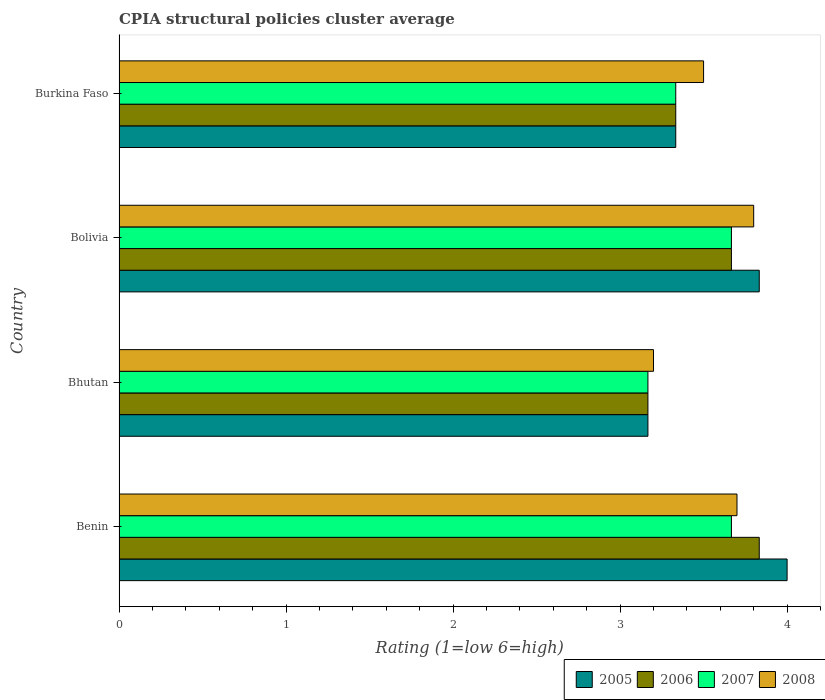How many groups of bars are there?
Your answer should be very brief. 4. Are the number of bars per tick equal to the number of legend labels?
Your response must be concise. Yes. Are the number of bars on each tick of the Y-axis equal?
Your answer should be compact. Yes. How many bars are there on the 2nd tick from the top?
Make the answer very short. 4. In how many cases, is the number of bars for a given country not equal to the number of legend labels?
Your answer should be very brief. 0. What is the CPIA rating in 2005 in Bolivia?
Your response must be concise. 3.83. Across all countries, what is the minimum CPIA rating in 2006?
Provide a short and direct response. 3.17. In which country was the CPIA rating in 2007 maximum?
Give a very brief answer. Benin. In which country was the CPIA rating in 2005 minimum?
Keep it short and to the point. Bhutan. What is the total CPIA rating in 2006 in the graph?
Offer a very short reply. 14. What is the difference between the CPIA rating in 2005 in Benin and that in Bolivia?
Your answer should be compact. 0.17. What is the average CPIA rating in 2006 per country?
Your answer should be compact. 3.5. What is the difference between the CPIA rating in 2008 and CPIA rating in 2007 in Burkina Faso?
Your answer should be very brief. 0.17. In how many countries, is the CPIA rating in 2007 greater than 1.4 ?
Give a very brief answer. 4. What is the ratio of the CPIA rating in 2007 in Benin to that in Burkina Faso?
Provide a short and direct response. 1.1. Is the CPIA rating in 2006 in Bhutan less than that in Bolivia?
Ensure brevity in your answer.  Yes. What is the difference between the highest and the second highest CPIA rating in 2007?
Make the answer very short. 0. What is the difference between the highest and the lowest CPIA rating in 2006?
Your response must be concise. 0.67. In how many countries, is the CPIA rating in 2008 greater than the average CPIA rating in 2008 taken over all countries?
Keep it short and to the point. 2. Is it the case that in every country, the sum of the CPIA rating in 2008 and CPIA rating in 2005 is greater than the sum of CPIA rating in 2007 and CPIA rating in 2006?
Give a very brief answer. No. What does the 3rd bar from the top in Benin represents?
Keep it short and to the point. 2006. Is it the case that in every country, the sum of the CPIA rating in 2008 and CPIA rating in 2005 is greater than the CPIA rating in 2007?
Give a very brief answer. Yes. How many bars are there?
Give a very brief answer. 16. Are the values on the major ticks of X-axis written in scientific E-notation?
Your answer should be very brief. No. Does the graph contain any zero values?
Give a very brief answer. No. How many legend labels are there?
Your response must be concise. 4. How are the legend labels stacked?
Your answer should be compact. Horizontal. What is the title of the graph?
Offer a terse response. CPIA structural policies cluster average. What is the Rating (1=low 6=high) in 2005 in Benin?
Make the answer very short. 4. What is the Rating (1=low 6=high) in 2006 in Benin?
Your answer should be compact. 3.83. What is the Rating (1=low 6=high) of 2007 in Benin?
Your response must be concise. 3.67. What is the Rating (1=low 6=high) in 2005 in Bhutan?
Ensure brevity in your answer.  3.17. What is the Rating (1=low 6=high) of 2006 in Bhutan?
Give a very brief answer. 3.17. What is the Rating (1=low 6=high) in 2007 in Bhutan?
Offer a terse response. 3.17. What is the Rating (1=low 6=high) of 2008 in Bhutan?
Your answer should be very brief. 3.2. What is the Rating (1=low 6=high) of 2005 in Bolivia?
Keep it short and to the point. 3.83. What is the Rating (1=low 6=high) of 2006 in Bolivia?
Your answer should be very brief. 3.67. What is the Rating (1=low 6=high) of 2007 in Bolivia?
Provide a short and direct response. 3.67. What is the Rating (1=low 6=high) of 2005 in Burkina Faso?
Offer a very short reply. 3.33. What is the Rating (1=low 6=high) of 2006 in Burkina Faso?
Offer a very short reply. 3.33. What is the Rating (1=low 6=high) in 2007 in Burkina Faso?
Your answer should be very brief. 3.33. What is the Rating (1=low 6=high) of 2008 in Burkina Faso?
Offer a very short reply. 3.5. Across all countries, what is the maximum Rating (1=low 6=high) of 2005?
Ensure brevity in your answer.  4. Across all countries, what is the maximum Rating (1=low 6=high) in 2006?
Ensure brevity in your answer.  3.83. Across all countries, what is the maximum Rating (1=low 6=high) in 2007?
Your answer should be very brief. 3.67. Across all countries, what is the minimum Rating (1=low 6=high) in 2005?
Provide a succinct answer. 3.17. Across all countries, what is the minimum Rating (1=low 6=high) in 2006?
Your response must be concise. 3.17. Across all countries, what is the minimum Rating (1=low 6=high) in 2007?
Ensure brevity in your answer.  3.17. What is the total Rating (1=low 6=high) of 2005 in the graph?
Your answer should be compact. 14.33. What is the total Rating (1=low 6=high) in 2007 in the graph?
Give a very brief answer. 13.83. What is the difference between the Rating (1=low 6=high) of 2006 in Benin and that in Bhutan?
Provide a short and direct response. 0.67. What is the difference between the Rating (1=low 6=high) of 2005 in Benin and that in Bolivia?
Make the answer very short. 0.17. What is the difference between the Rating (1=low 6=high) of 2007 in Benin and that in Bolivia?
Provide a succinct answer. 0. What is the difference between the Rating (1=low 6=high) in 2008 in Benin and that in Bolivia?
Provide a short and direct response. -0.1. What is the difference between the Rating (1=low 6=high) in 2005 in Benin and that in Burkina Faso?
Offer a terse response. 0.67. What is the difference between the Rating (1=low 6=high) of 2006 in Benin and that in Burkina Faso?
Your answer should be compact. 0.5. What is the difference between the Rating (1=low 6=high) of 2007 in Benin and that in Burkina Faso?
Make the answer very short. 0.33. What is the difference between the Rating (1=low 6=high) in 2006 in Bhutan and that in Burkina Faso?
Ensure brevity in your answer.  -0.17. What is the difference between the Rating (1=low 6=high) of 2008 in Bhutan and that in Burkina Faso?
Your answer should be very brief. -0.3. What is the difference between the Rating (1=low 6=high) in 2005 in Bolivia and that in Burkina Faso?
Your answer should be compact. 0.5. What is the difference between the Rating (1=low 6=high) in 2007 in Bolivia and that in Burkina Faso?
Your answer should be very brief. 0.33. What is the difference between the Rating (1=low 6=high) in 2008 in Bolivia and that in Burkina Faso?
Your answer should be compact. 0.3. What is the difference between the Rating (1=low 6=high) of 2005 in Benin and the Rating (1=low 6=high) of 2008 in Bhutan?
Offer a very short reply. 0.8. What is the difference between the Rating (1=low 6=high) of 2006 in Benin and the Rating (1=low 6=high) of 2007 in Bhutan?
Make the answer very short. 0.67. What is the difference between the Rating (1=low 6=high) of 2006 in Benin and the Rating (1=low 6=high) of 2008 in Bhutan?
Your response must be concise. 0.63. What is the difference between the Rating (1=low 6=high) of 2007 in Benin and the Rating (1=low 6=high) of 2008 in Bhutan?
Your answer should be compact. 0.47. What is the difference between the Rating (1=low 6=high) of 2005 in Benin and the Rating (1=low 6=high) of 2006 in Bolivia?
Make the answer very short. 0.33. What is the difference between the Rating (1=low 6=high) of 2007 in Benin and the Rating (1=low 6=high) of 2008 in Bolivia?
Offer a very short reply. -0.13. What is the difference between the Rating (1=low 6=high) in 2005 in Benin and the Rating (1=low 6=high) in 2007 in Burkina Faso?
Offer a very short reply. 0.67. What is the difference between the Rating (1=low 6=high) in 2006 in Benin and the Rating (1=low 6=high) in 2007 in Burkina Faso?
Your answer should be compact. 0.5. What is the difference between the Rating (1=low 6=high) in 2006 in Benin and the Rating (1=low 6=high) in 2008 in Burkina Faso?
Your answer should be compact. 0.33. What is the difference between the Rating (1=low 6=high) of 2005 in Bhutan and the Rating (1=low 6=high) of 2006 in Bolivia?
Your response must be concise. -0.5. What is the difference between the Rating (1=low 6=high) of 2005 in Bhutan and the Rating (1=low 6=high) of 2008 in Bolivia?
Ensure brevity in your answer.  -0.63. What is the difference between the Rating (1=low 6=high) of 2006 in Bhutan and the Rating (1=low 6=high) of 2007 in Bolivia?
Offer a very short reply. -0.5. What is the difference between the Rating (1=low 6=high) in 2006 in Bhutan and the Rating (1=low 6=high) in 2008 in Bolivia?
Offer a very short reply. -0.63. What is the difference between the Rating (1=low 6=high) of 2007 in Bhutan and the Rating (1=low 6=high) of 2008 in Bolivia?
Offer a very short reply. -0.63. What is the difference between the Rating (1=low 6=high) in 2005 in Bhutan and the Rating (1=low 6=high) in 2007 in Burkina Faso?
Your answer should be very brief. -0.17. What is the difference between the Rating (1=low 6=high) of 2006 in Bhutan and the Rating (1=low 6=high) of 2008 in Burkina Faso?
Offer a very short reply. -0.33. What is the difference between the Rating (1=low 6=high) of 2007 in Bhutan and the Rating (1=low 6=high) of 2008 in Burkina Faso?
Provide a succinct answer. -0.33. What is the difference between the Rating (1=low 6=high) in 2007 in Bolivia and the Rating (1=low 6=high) in 2008 in Burkina Faso?
Provide a short and direct response. 0.17. What is the average Rating (1=low 6=high) of 2005 per country?
Provide a short and direct response. 3.58. What is the average Rating (1=low 6=high) in 2006 per country?
Provide a short and direct response. 3.5. What is the average Rating (1=low 6=high) in 2007 per country?
Provide a short and direct response. 3.46. What is the average Rating (1=low 6=high) of 2008 per country?
Your response must be concise. 3.55. What is the difference between the Rating (1=low 6=high) of 2005 and Rating (1=low 6=high) of 2007 in Benin?
Your answer should be very brief. 0.33. What is the difference between the Rating (1=low 6=high) in 2006 and Rating (1=low 6=high) in 2008 in Benin?
Provide a succinct answer. 0.13. What is the difference between the Rating (1=low 6=high) in 2007 and Rating (1=low 6=high) in 2008 in Benin?
Provide a succinct answer. -0.03. What is the difference between the Rating (1=low 6=high) of 2005 and Rating (1=low 6=high) of 2008 in Bhutan?
Make the answer very short. -0.03. What is the difference between the Rating (1=low 6=high) of 2006 and Rating (1=low 6=high) of 2008 in Bhutan?
Give a very brief answer. -0.03. What is the difference between the Rating (1=low 6=high) in 2007 and Rating (1=low 6=high) in 2008 in Bhutan?
Offer a terse response. -0.03. What is the difference between the Rating (1=low 6=high) in 2005 and Rating (1=low 6=high) in 2006 in Bolivia?
Make the answer very short. 0.17. What is the difference between the Rating (1=low 6=high) of 2005 and Rating (1=low 6=high) of 2007 in Bolivia?
Provide a succinct answer. 0.17. What is the difference between the Rating (1=low 6=high) in 2006 and Rating (1=low 6=high) in 2008 in Bolivia?
Ensure brevity in your answer.  -0.13. What is the difference between the Rating (1=low 6=high) of 2007 and Rating (1=low 6=high) of 2008 in Bolivia?
Keep it short and to the point. -0.13. What is the difference between the Rating (1=low 6=high) in 2005 and Rating (1=low 6=high) in 2007 in Burkina Faso?
Your response must be concise. 0. What is the difference between the Rating (1=low 6=high) of 2006 and Rating (1=low 6=high) of 2007 in Burkina Faso?
Provide a succinct answer. 0. What is the difference between the Rating (1=low 6=high) in 2006 and Rating (1=low 6=high) in 2008 in Burkina Faso?
Offer a very short reply. -0.17. What is the ratio of the Rating (1=low 6=high) in 2005 in Benin to that in Bhutan?
Give a very brief answer. 1.26. What is the ratio of the Rating (1=low 6=high) in 2006 in Benin to that in Bhutan?
Provide a short and direct response. 1.21. What is the ratio of the Rating (1=low 6=high) in 2007 in Benin to that in Bhutan?
Offer a terse response. 1.16. What is the ratio of the Rating (1=low 6=high) of 2008 in Benin to that in Bhutan?
Keep it short and to the point. 1.16. What is the ratio of the Rating (1=low 6=high) of 2005 in Benin to that in Bolivia?
Your response must be concise. 1.04. What is the ratio of the Rating (1=low 6=high) of 2006 in Benin to that in Bolivia?
Your answer should be compact. 1.05. What is the ratio of the Rating (1=low 6=high) in 2007 in Benin to that in Bolivia?
Offer a terse response. 1. What is the ratio of the Rating (1=low 6=high) of 2008 in Benin to that in Bolivia?
Your response must be concise. 0.97. What is the ratio of the Rating (1=low 6=high) of 2006 in Benin to that in Burkina Faso?
Your answer should be very brief. 1.15. What is the ratio of the Rating (1=low 6=high) of 2008 in Benin to that in Burkina Faso?
Offer a very short reply. 1.06. What is the ratio of the Rating (1=low 6=high) of 2005 in Bhutan to that in Bolivia?
Your answer should be compact. 0.83. What is the ratio of the Rating (1=low 6=high) of 2006 in Bhutan to that in Bolivia?
Your answer should be very brief. 0.86. What is the ratio of the Rating (1=low 6=high) in 2007 in Bhutan to that in Bolivia?
Give a very brief answer. 0.86. What is the ratio of the Rating (1=low 6=high) of 2008 in Bhutan to that in Bolivia?
Your answer should be very brief. 0.84. What is the ratio of the Rating (1=low 6=high) of 2005 in Bhutan to that in Burkina Faso?
Offer a terse response. 0.95. What is the ratio of the Rating (1=low 6=high) in 2007 in Bhutan to that in Burkina Faso?
Keep it short and to the point. 0.95. What is the ratio of the Rating (1=low 6=high) in 2008 in Bhutan to that in Burkina Faso?
Your response must be concise. 0.91. What is the ratio of the Rating (1=low 6=high) of 2005 in Bolivia to that in Burkina Faso?
Offer a terse response. 1.15. What is the ratio of the Rating (1=low 6=high) of 2007 in Bolivia to that in Burkina Faso?
Your response must be concise. 1.1. What is the ratio of the Rating (1=low 6=high) in 2008 in Bolivia to that in Burkina Faso?
Your answer should be compact. 1.09. What is the difference between the highest and the second highest Rating (1=low 6=high) of 2005?
Give a very brief answer. 0.17. What is the difference between the highest and the second highest Rating (1=low 6=high) of 2007?
Your answer should be compact. 0. What is the difference between the highest and the lowest Rating (1=low 6=high) of 2005?
Your answer should be very brief. 0.83. What is the difference between the highest and the lowest Rating (1=low 6=high) of 2006?
Your response must be concise. 0.67. What is the difference between the highest and the lowest Rating (1=low 6=high) of 2008?
Keep it short and to the point. 0.6. 